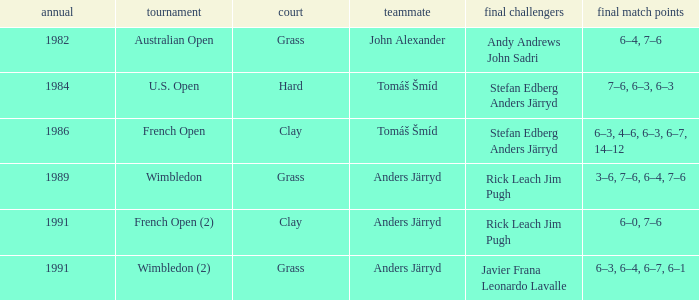Who was his partner in 1989?  Anders Järryd. 